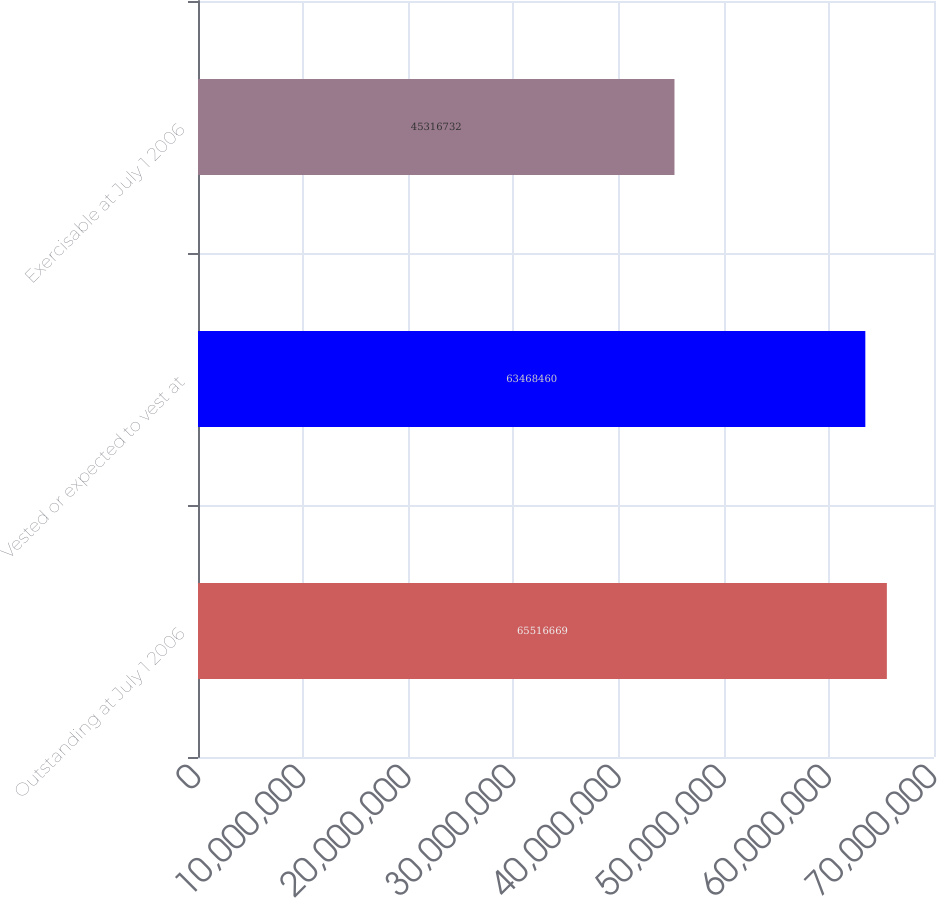Convert chart to OTSL. <chart><loc_0><loc_0><loc_500><loc_500><bar_chart><fcel>Outstanding at July 1 2006<fcel>Vested or expected to vest at<fcel>Exercisable at July 1 2006<nl><fcel>6.55167e+07<fcel>6.34685e+07<fcel>4.53167e+07<nl></chart> 